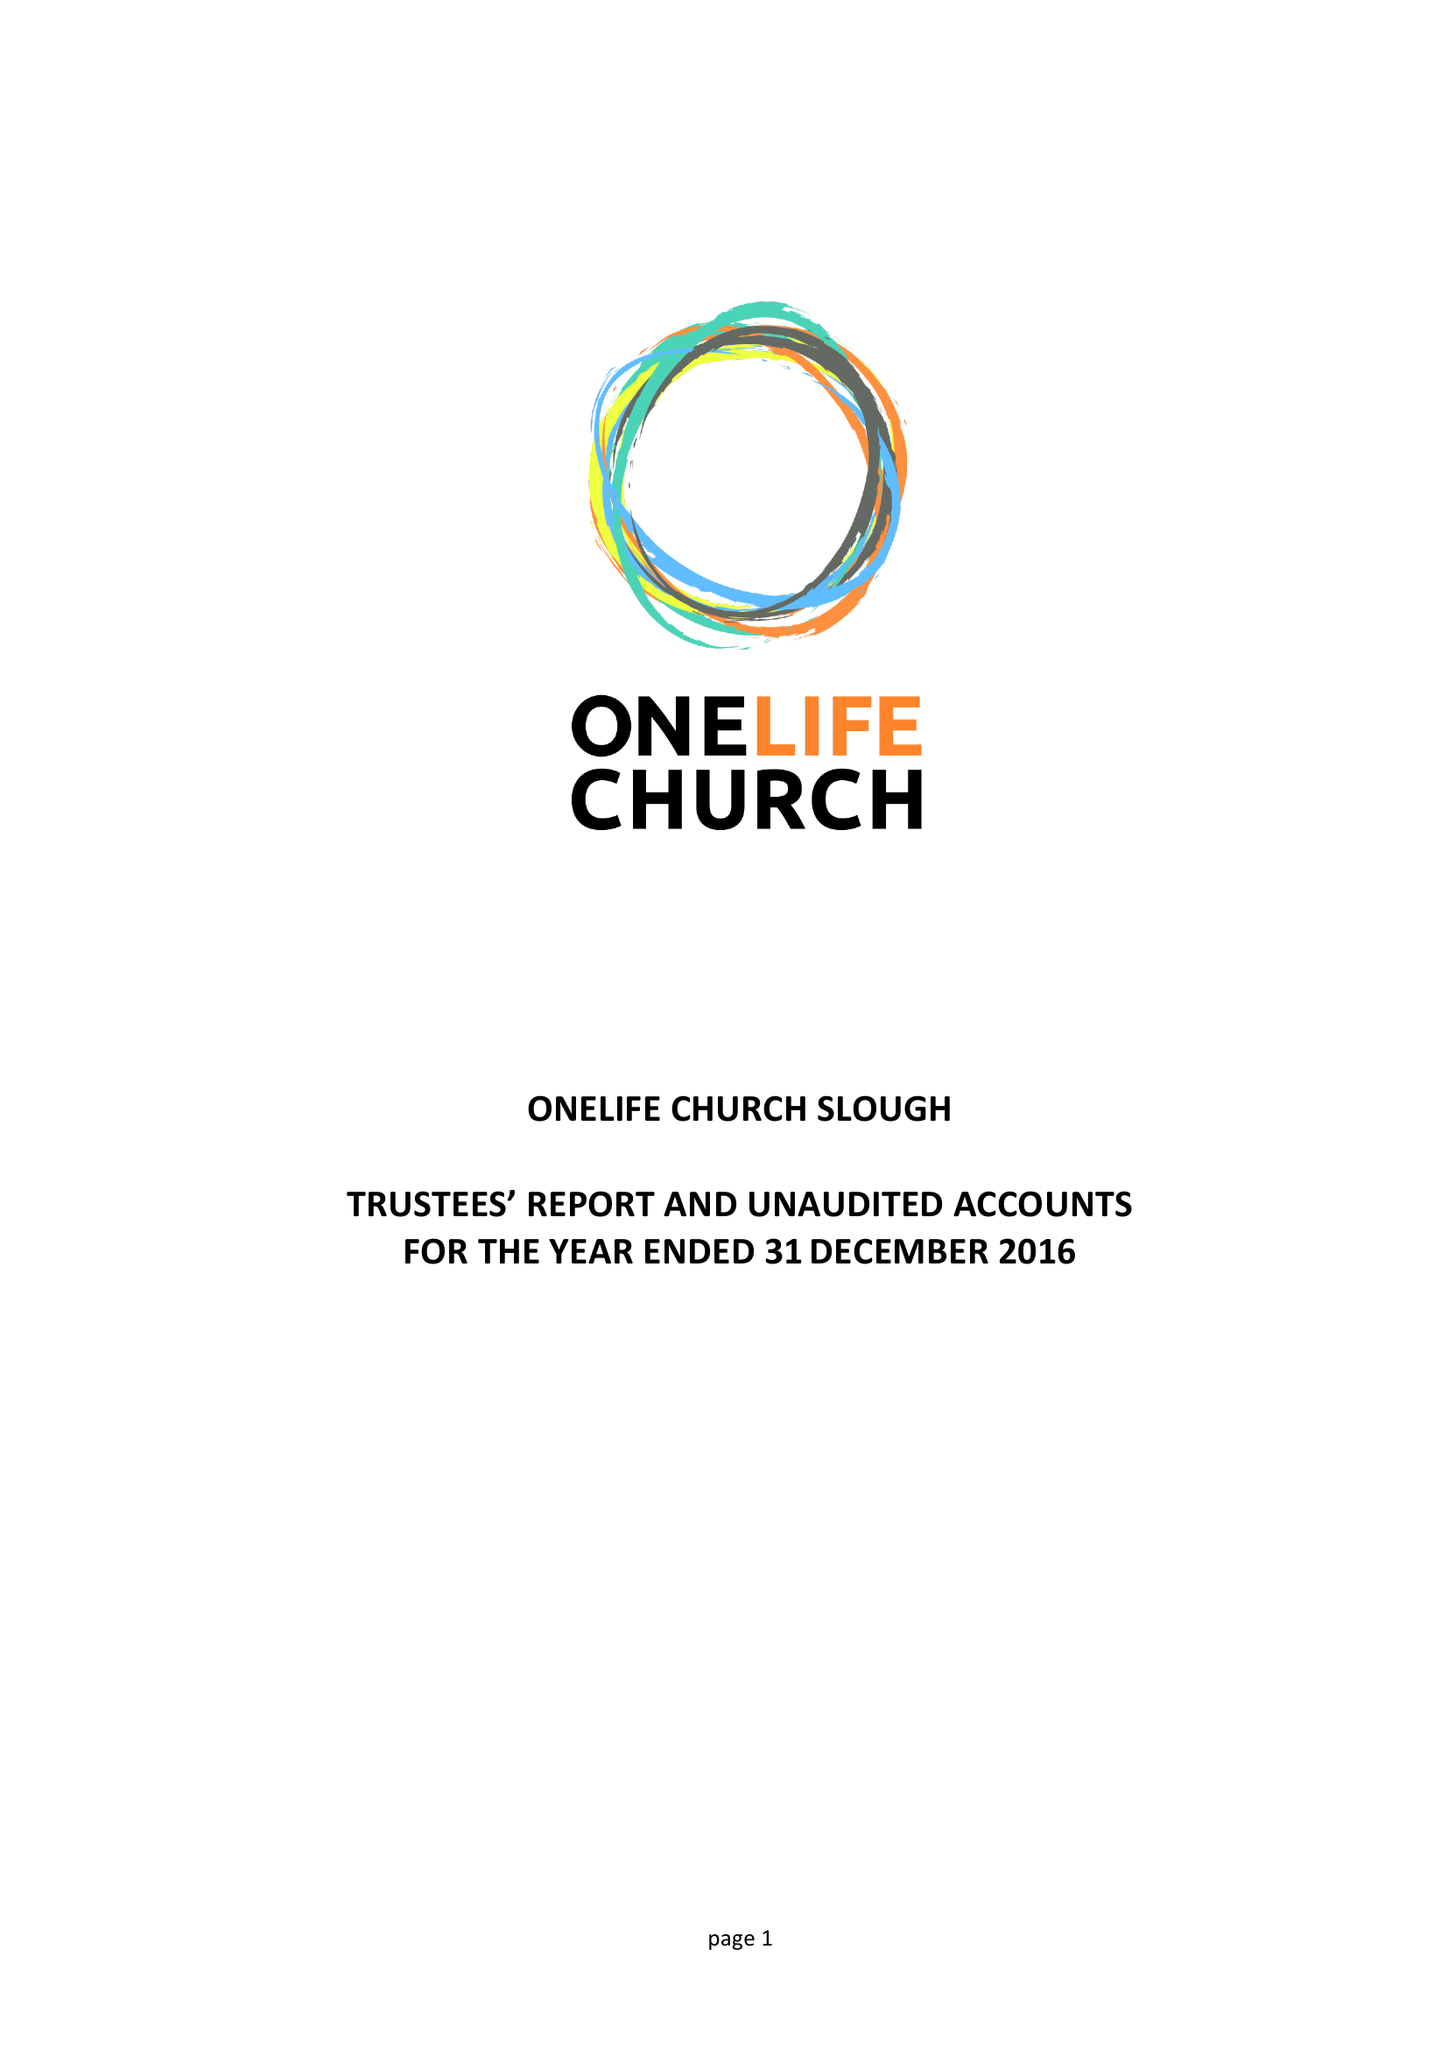What is the value for the charity_name?
Answer the question using a single word or phrase. Onelife Church Slough 